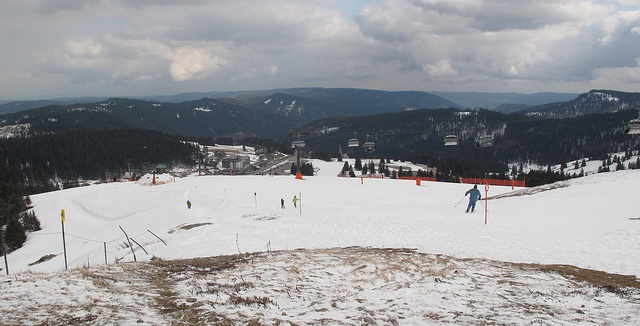Describe the objects in this image and their specific colors. I can see people in darkgray, gray, blue, and lightgray tones, people in darkgray, gray, white, and black tones, people in darkgray, gray, and lightgray tones, people in darkgray, olive, gray, and lightgray tones, and skis in darkgray, teal, and gray tones in this image. 